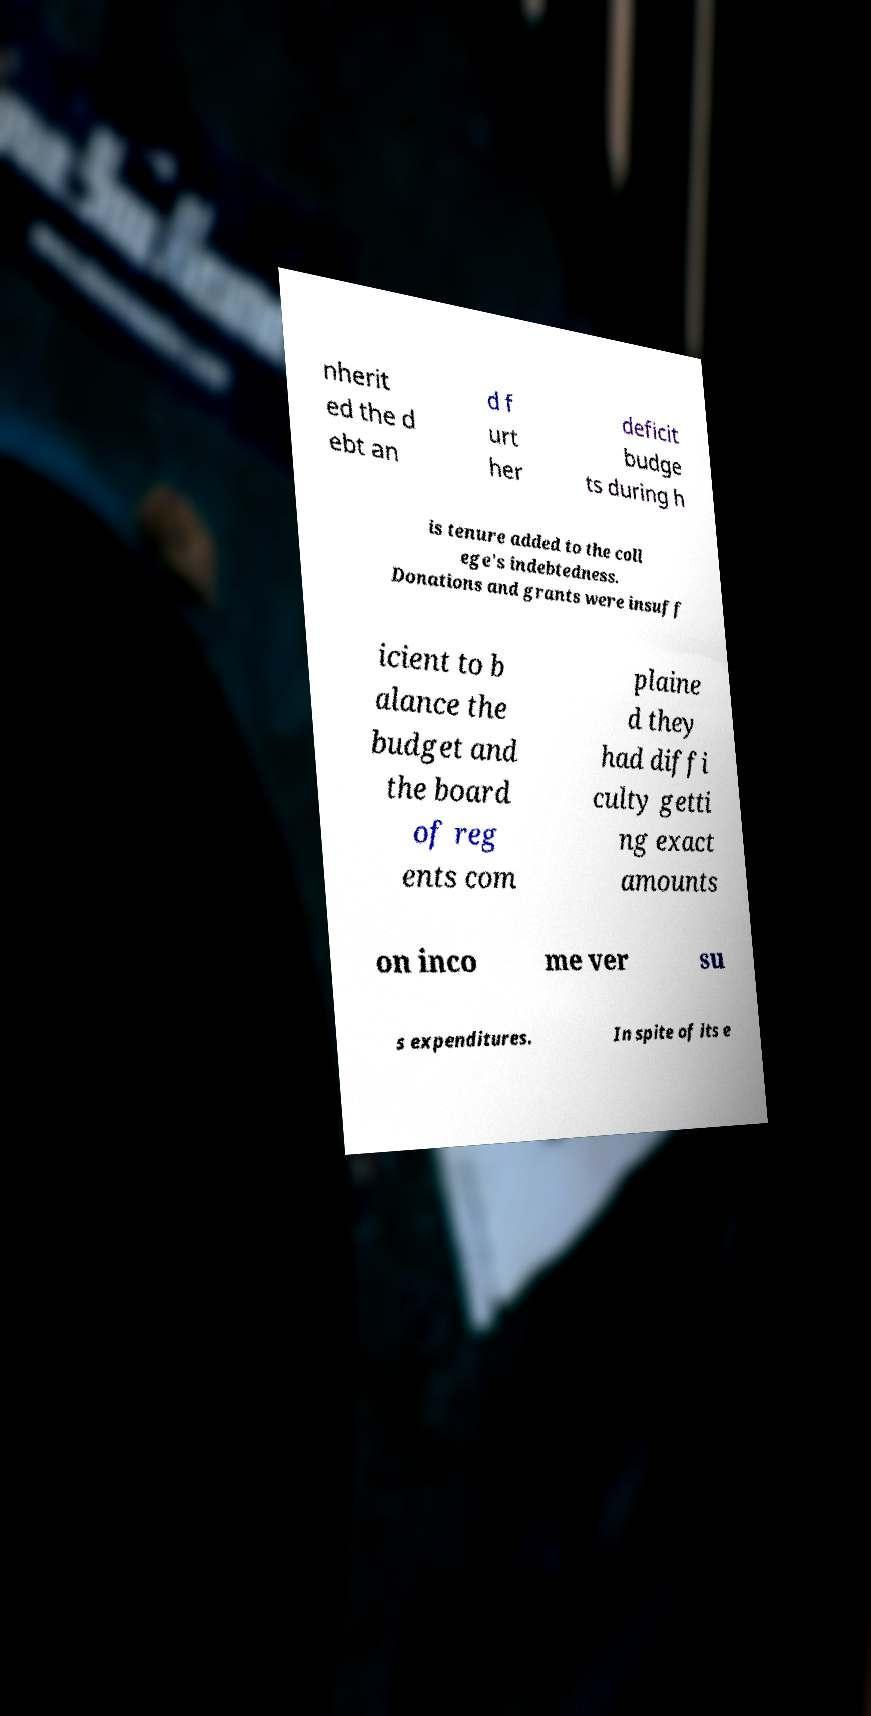Could you extract and type out the text from this image? nherit ed the d ebt an d f urt her deficit budge ts during h is tenure added to the coll ege's indebtedness. Donations and grants were insuff icient to b alance the budget and the board of reg ents com plaine d they had diffi culty getti ng exact amounts on inco me ver su s expenditures. In spite of its e 